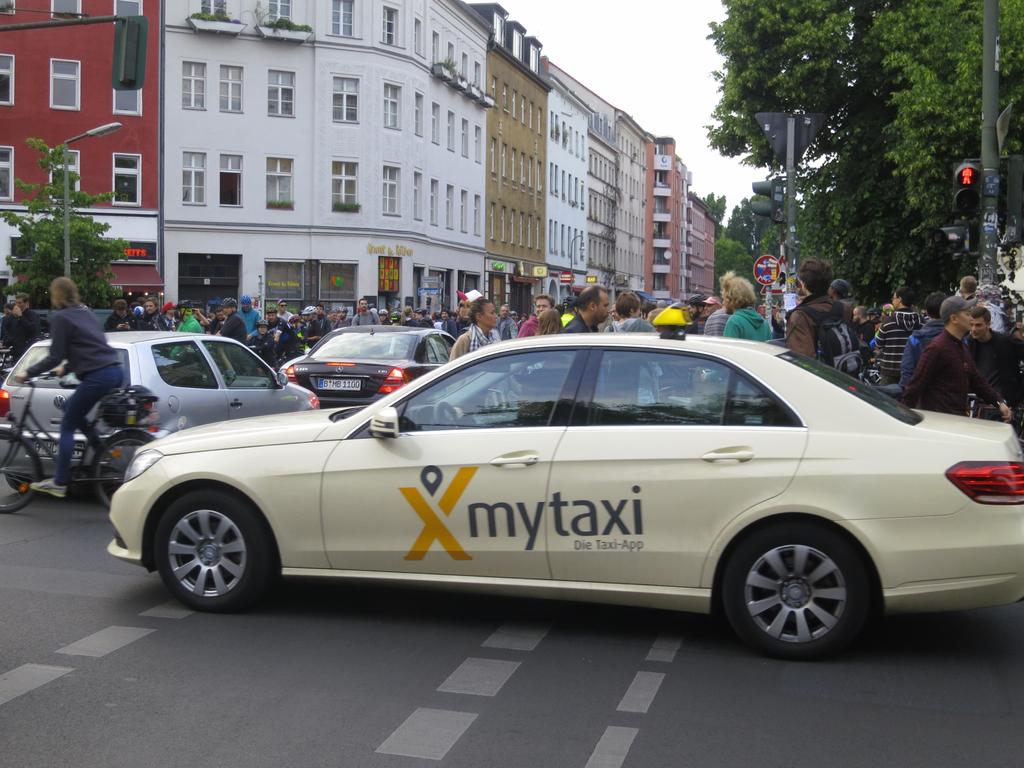What is the company for this cab service?
Provide a succinct answer. Mytaxi. What is the app for mytaxi called?
Provide a succinct answer. Die taxi-app. 